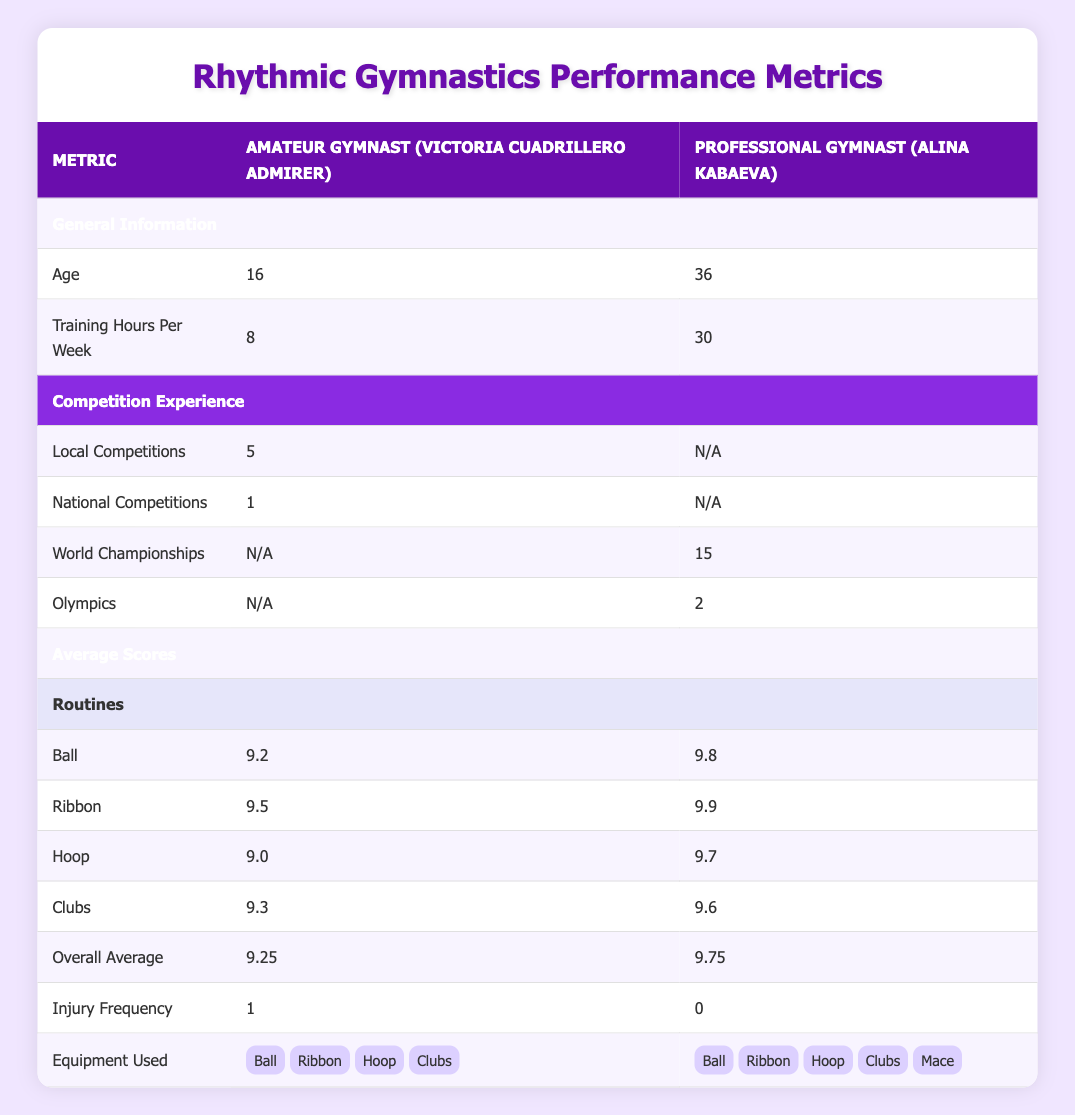What is the age difference between the amateur gymnast and the professional gymnast? The amateur gymnast is 16 years old, and the professional gymnast is 36 years old. To find the age difference, we subtract the age of the amateur gymnast from the professional gymnast: 36 - 16 = 20.
Answer: 20 How many more training hours does the professional gymnast have compared to the amateur gymnast? The amateur gymnast trains for 8 hours per week, while the professional gymnast trains for 30 hours per week. To find the difference, we subtract the amateur's training hours from the professional's: 30 - 8 = 22.
Answer: 22 What is the overall average score for the amateur gymnast, and how does it compare to the professional gymnast's overall average score? The amateur gymnast's overall average score is 9.25, and the professional gymnast's overall average score is 9.75. Comparing the two, 9.75 - 9.25 = 0.50, indicating the professional has a higher score by 0.50.
Answer: 9.25, professional is higher by 0.50 Did either gymnast have experience at the Olympics? The amateur gymnast has no Olympic experience (N/A), while the professional gymnast has participated in the Olympics 2 times (indicating true experience). Therefore, the answer would focus on the presence of experience.
Answer: Yes, the professional gymnast has Olympic experience Which gymnast has a lower injury frequency, and what are the specific frequencies? The amateur gymnast has an injury frequency of 1, while the professional gymnast has an injury frequency of 0. Thus, the professional gymnast has a lower injury frequency. This is arrived at by directly comparing the values provided.
Answer: The professional gymnast has a lower injury frequency What is the total number of competitions experienced by the amateur gymnast? The amateur gymnast has participated in 5 local competitions and 1 national competition. To find the total, we add these two values: 5 + 1 = 6. Thus, that is the total number of competitions.
Answer: 6 competitions How does the average score for the 'Ball' routine of the amateur gymnast compare to the professional gymnast's score? The amateur gymnast scored 9.2 on the 'Ball' routine, while the professional gymnast scored 9.8. By subtracting the amateur's score from the professional's, we find: 9.8 - 9.2 = 0.6, indicating the professional gymnast scored higher by that amount.
Answer: The professional gymnast scored 0.6 higher Is it true that the amateur gymnast uses the same types of equipment as the professional gymnast? The amateur gymnast uses a ball, ribbon, hoop, and clubs, while the professional gymnast uses a ball, ribbon, hoop, clubs, and an additional mace. Since there is one extra piece of equipment (mace) for the professional, they do not have the same types of equipment.
Answer: No, the professional gymnast uses more equipment What are the average scores for the 'Ribbon' routine for both gymnasts, and which one is higher? The amateur gymnast has a score of 9.5 for the 'Ribbon' routine, while the professional gymnast scored 9.9. Comparing these scores: 9.9 is greater than 9.5, indicating the professional's score is higher. Therefore, we can summarize the findings succinctly.
Answer: The professional's score is higher at 9.9 